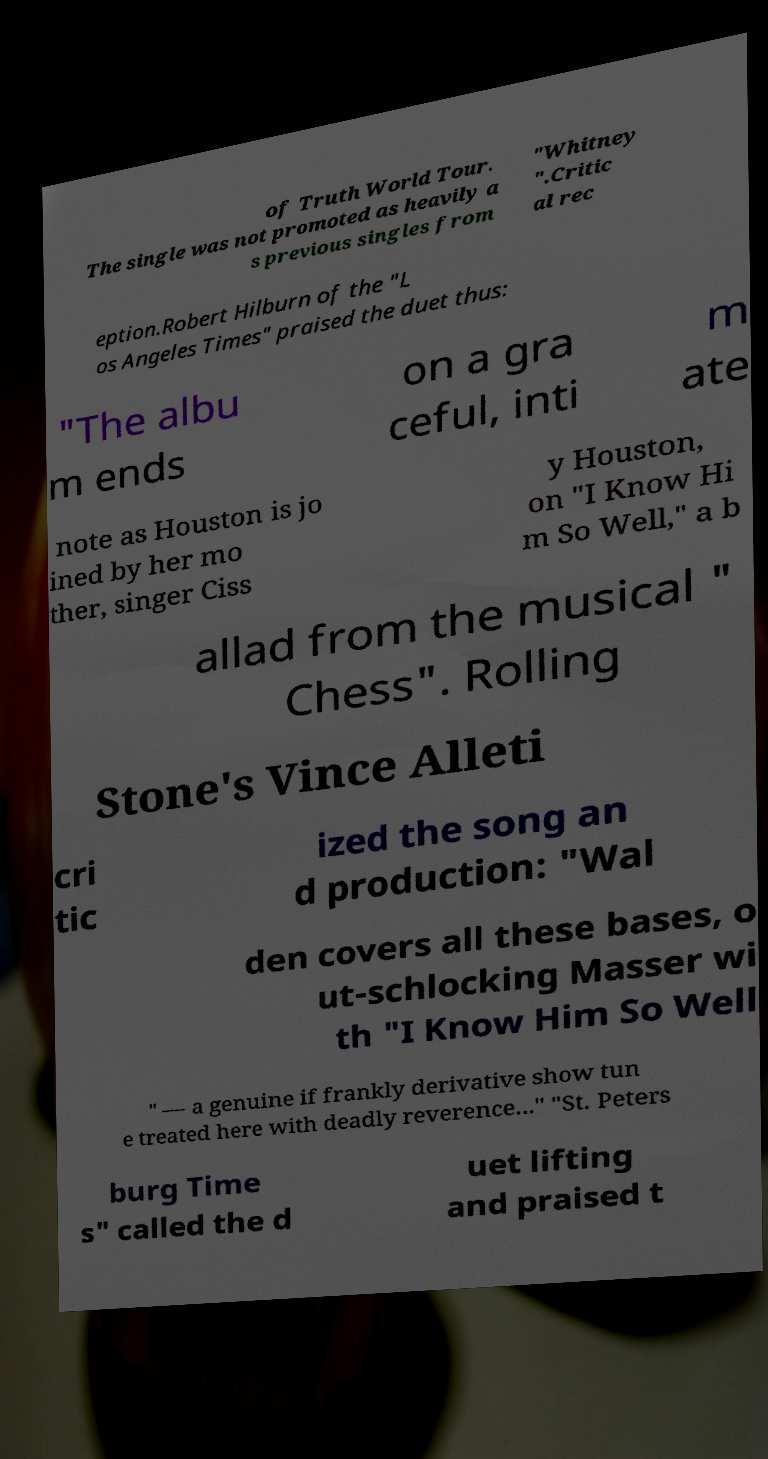I need the written content from this picture converted into text. Can you do that? of Truth World Tour. The single was not promoted as heavily a s previous singles from "Whitney ".Critic al rec eption.Robert Hilburn of the "L os Angeles Times" praised the duet thus: "The albu m ends on a gra ceful, inti m ate note as Houston is jo ined by her mo ther, singer Ciss y Houston, on "I Know Hi m So Well," a b allad from the musical " Chess". Rolling Stone's Vince Alleti cri tic ized the song an d production: "Wal den covers all these bases, o ut-schlocking Masser wi th "I Know Him So Well " — a genuine if frankly derivative show tun e treated here with deadly reverence..." "St. Peters burg Time s" called the d uet lifting and praised t 